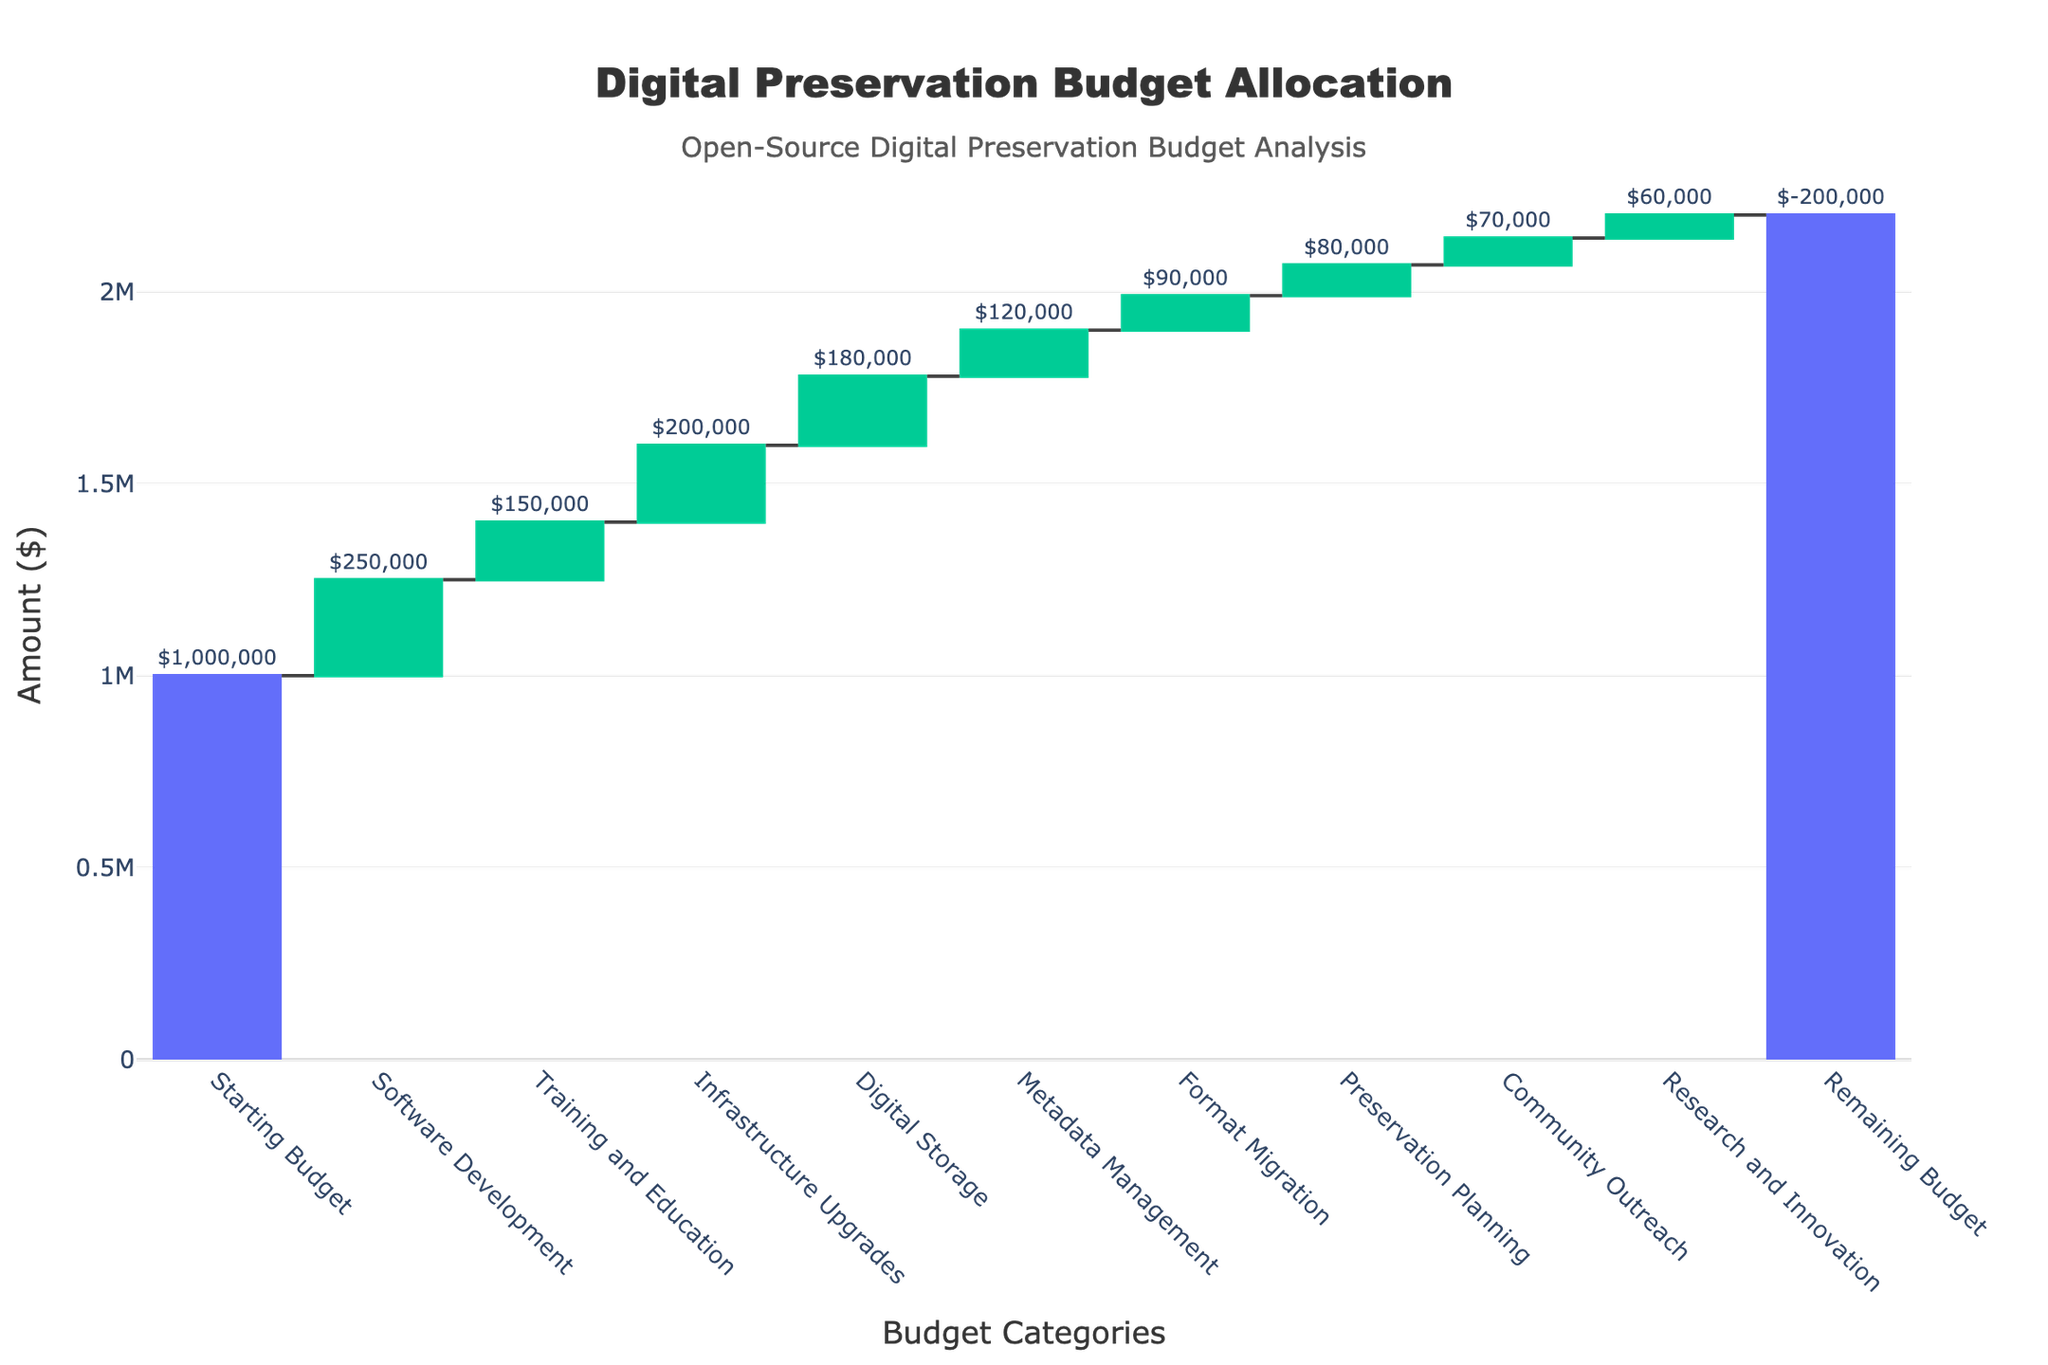Which category received the highest funding? By examining the height of the bars, Software Development has the highest funding since its bar extends the highest after the Starting Budget.
Answer: Software Development What is the total initial budget for digital preservation? The total initial budget is shown as the first bar, labeled as "Starting Budget".
Answer: $1,000,000 How much is allocated for Digital Storage? The label on the bar for Digital Storage shows the allocated amount.
Answer: $180,000 What is the remaining budget after all allocations? The remaining budget is indicated by the last bar labeled "Remaining Budget".
Answer: $200,000 How does the allocation for Research and Innovation compare to that for Training and Education? Compare the heights and labeled amounts of the Research and Innovation and Training and Education bars.
Answer: Research and Innovation ($60,000) is less than Training and Education ($150,000) What is the total amount allocated for Software Development, Training and Education, and Infrastructure Upgrades combined? Add the values for the three categories: $250,000 + $150,000 + $200,000 = $600,000.
Answer: $600,000 How much more is spent on Infrastructure Upgrades than Metadata Management? Subtract the amount for Metadata Management from Infrastructure Upgrades: $200,000 - $120,000 = $80,000.
Answer: $80,000 Which category received the least funding? The bar representing Format Migration is the shortest and shows the smallest value.
Answer: Format Migration What percentage of the total initial budget is allocated to Preservation Planning? Divide the amount for Preservation Planning by the initial budget and multiply by 100: ($80,000 / $1,000,000) * 100 = 8%.
Answer: 8% How much more is allocated to Digital Storage than to Format Migration? Subtract the amount for Format Migration from Digital Storage: $180,000 - $90,000 = $90,000.
Answer: $90,000 